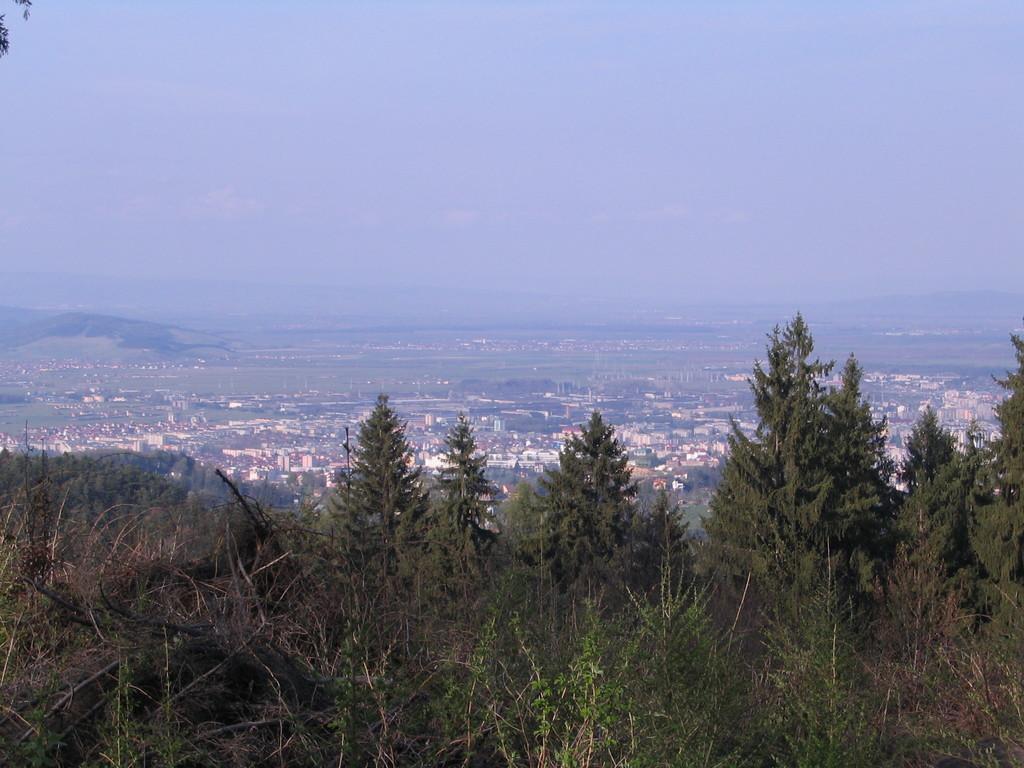Please provide a concise description of this image. In the foreground of the image we can see the trees. In the middle of the image we can see the buildings and trees. On the top of the image we can see the sky. 